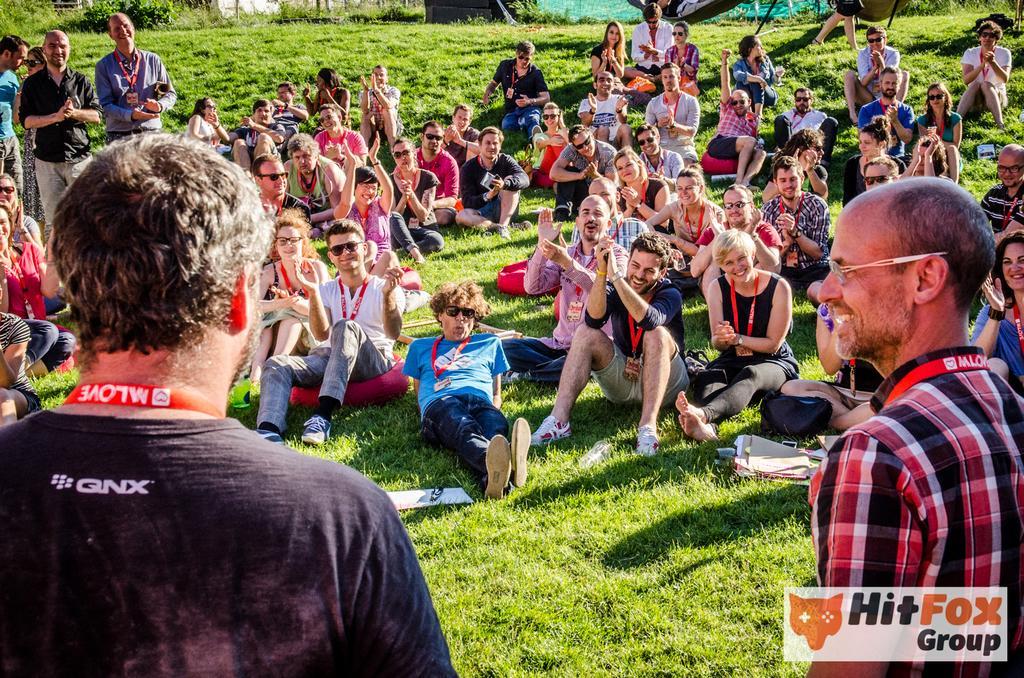Describe this image in one or two sentences. This is an outside view. At the bottom of the image I can see the grass. In the foreground two men are standing. In the background a crowd of people sitting on the ground. Everyone is smiling and clapping. 